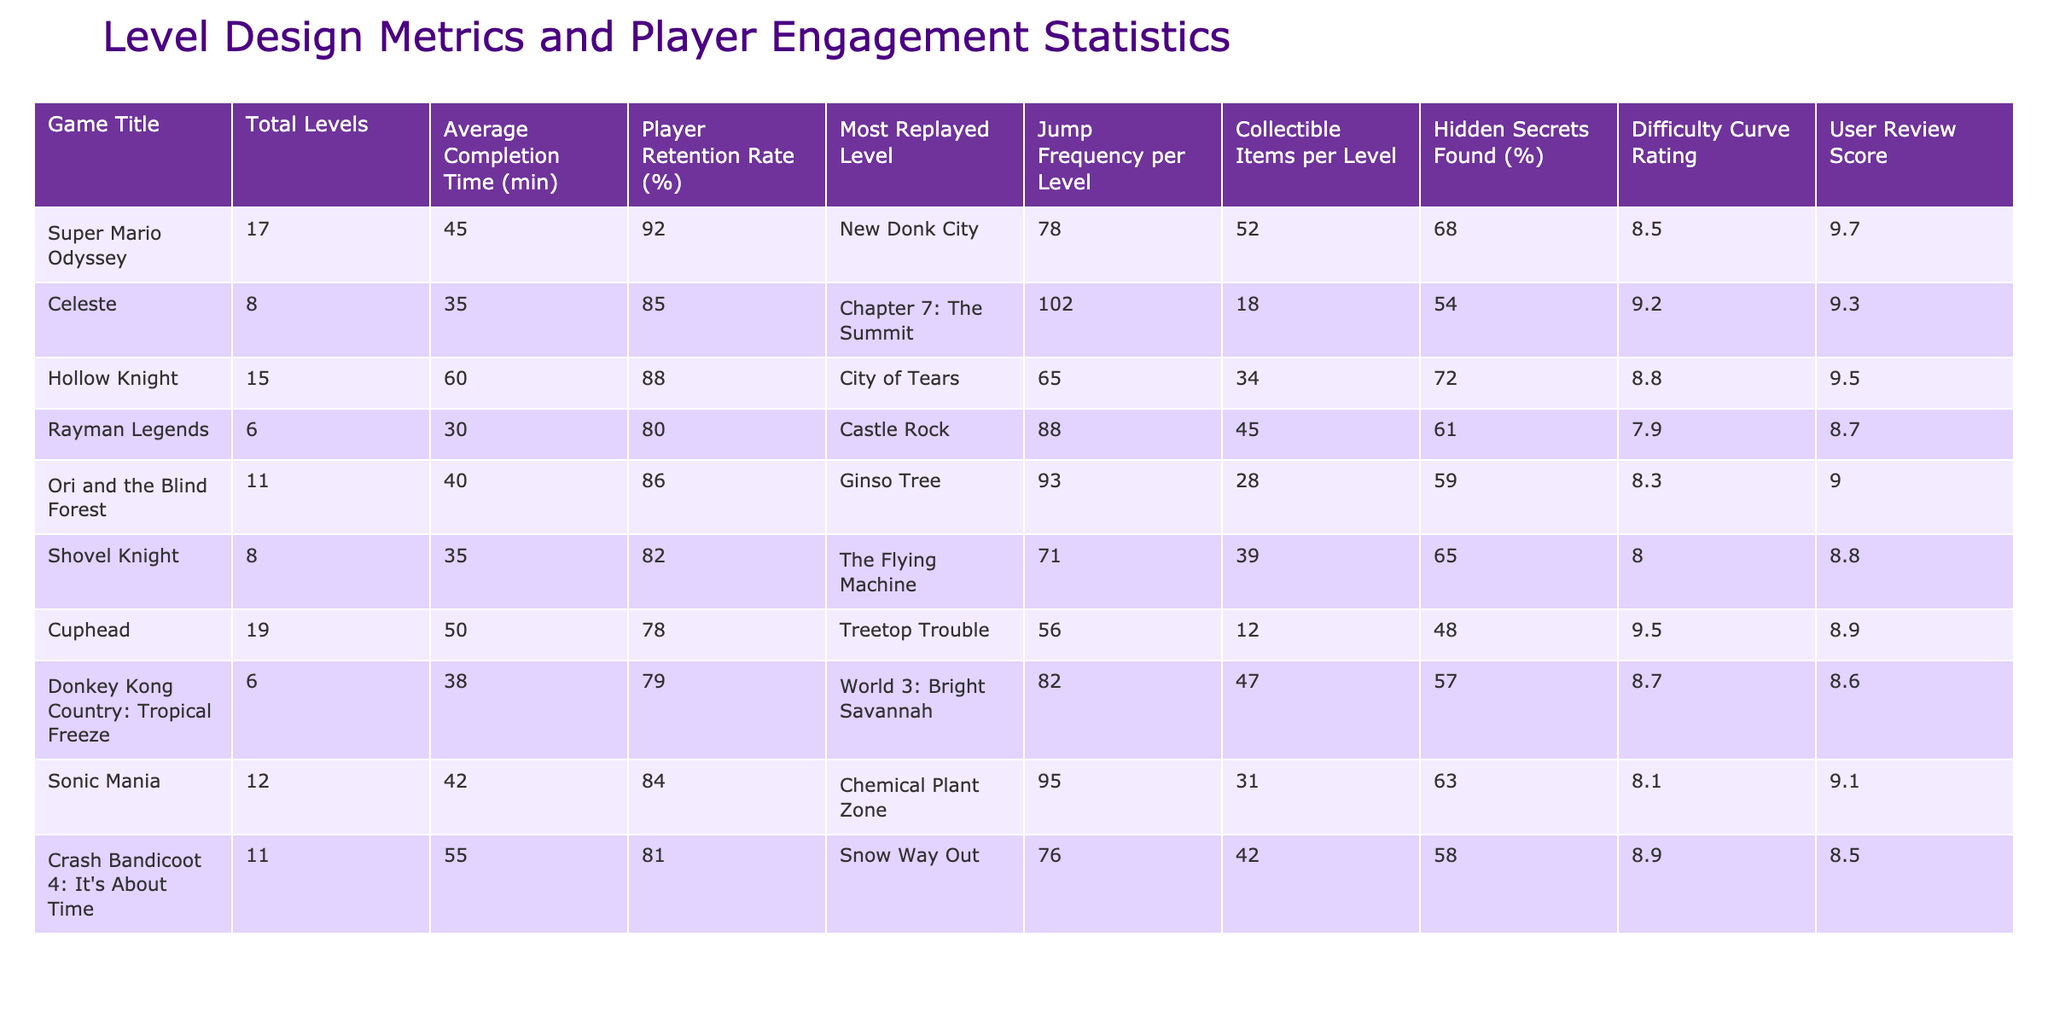What is the player retention rate for Hollow Knight? According to the table, the player retention rate for Hollow Knight is listed as 88%.
Answer: 88% Which game has the highest average completion time? The table shows that Hollow Knight has the highest average completion time at 60 minutes.
Answer: 60 What is the most replayed level in Super Mario Odyssey? The table indicates that the most replayed level in Super Mario Odyssey is New Donk City.
Answer: New Donk City Which game has the lowest user review score? Looking at the table, Rayman Legends has the lowest user review score at 8.7.
Answer: 8.7 What is the difference in jump frequency per level between Super Mario Odyssey and Cuphead? Super Mario Odyssey has a jump frequency of 78, while Cuphead's is 56. The difference is 78 - 56 = 22.
Answer: 22 How many total levels are there across all the games listed? By adding the Total Levels together from the table (17 + 8 + 15 + 6 + 11 + 8 + 19 + 6 + 12 + 11), the sum is 132 levels.
Answer: 132 Is the average completion time for Ori and the Blind Forest less than that of Donkey Kong Country: Tropical Freeze? Ori and the Blind Forest has an average completion time of 40 minutes, while Donkey Kong Country: Tropical Freeze has 38 minutes. Since 40 is greater than 38, the answer is No.
Answer: No Which game has the highest difficulty curve rating? According to the table, Cuphead has the highest difficulty curve rating at 9.5.
Answer: 9.5 What percentage of hidden secrets found is highest among the games? Comparing the percentages in the Hidden Secrets Found column, Hollow Knight has the highest at 72%.
Answer: 72% Calculate the average user review score for the games listed. The average user review score can be calculated by summing the scores (9.7 + 9.3 + 9.5 + 8.7 + 9.0 + 8.8 + 8.9 + 8.6 + 9.1 + 8.5 =  88.1) and dividing by the number of games (10), which results in 88.1/10 = 8.81.
Answer: 8.81 